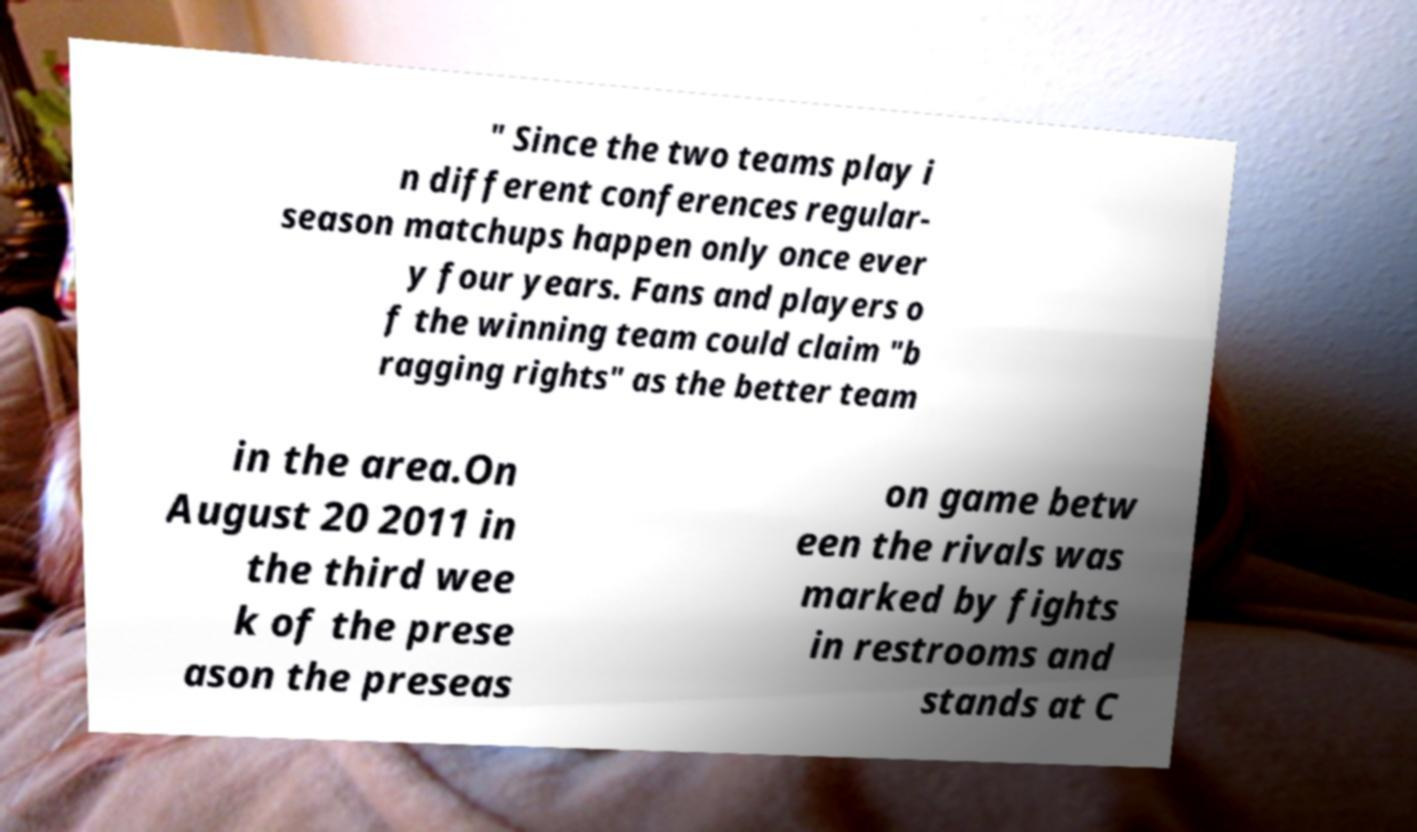There's text embedded in this image that I need extracted. Can you transcribe it verbatim? " Since the two teams play i n different conferences regular- season matchups happen only once ever y four years. Fans and players o f the winning team could claim "b ragging rights" as the better team in the area.On August 20 2011 in the third wee k of the prese ason the preseas on game betw een the rivals was marked by fights in restrooms and stands at C 